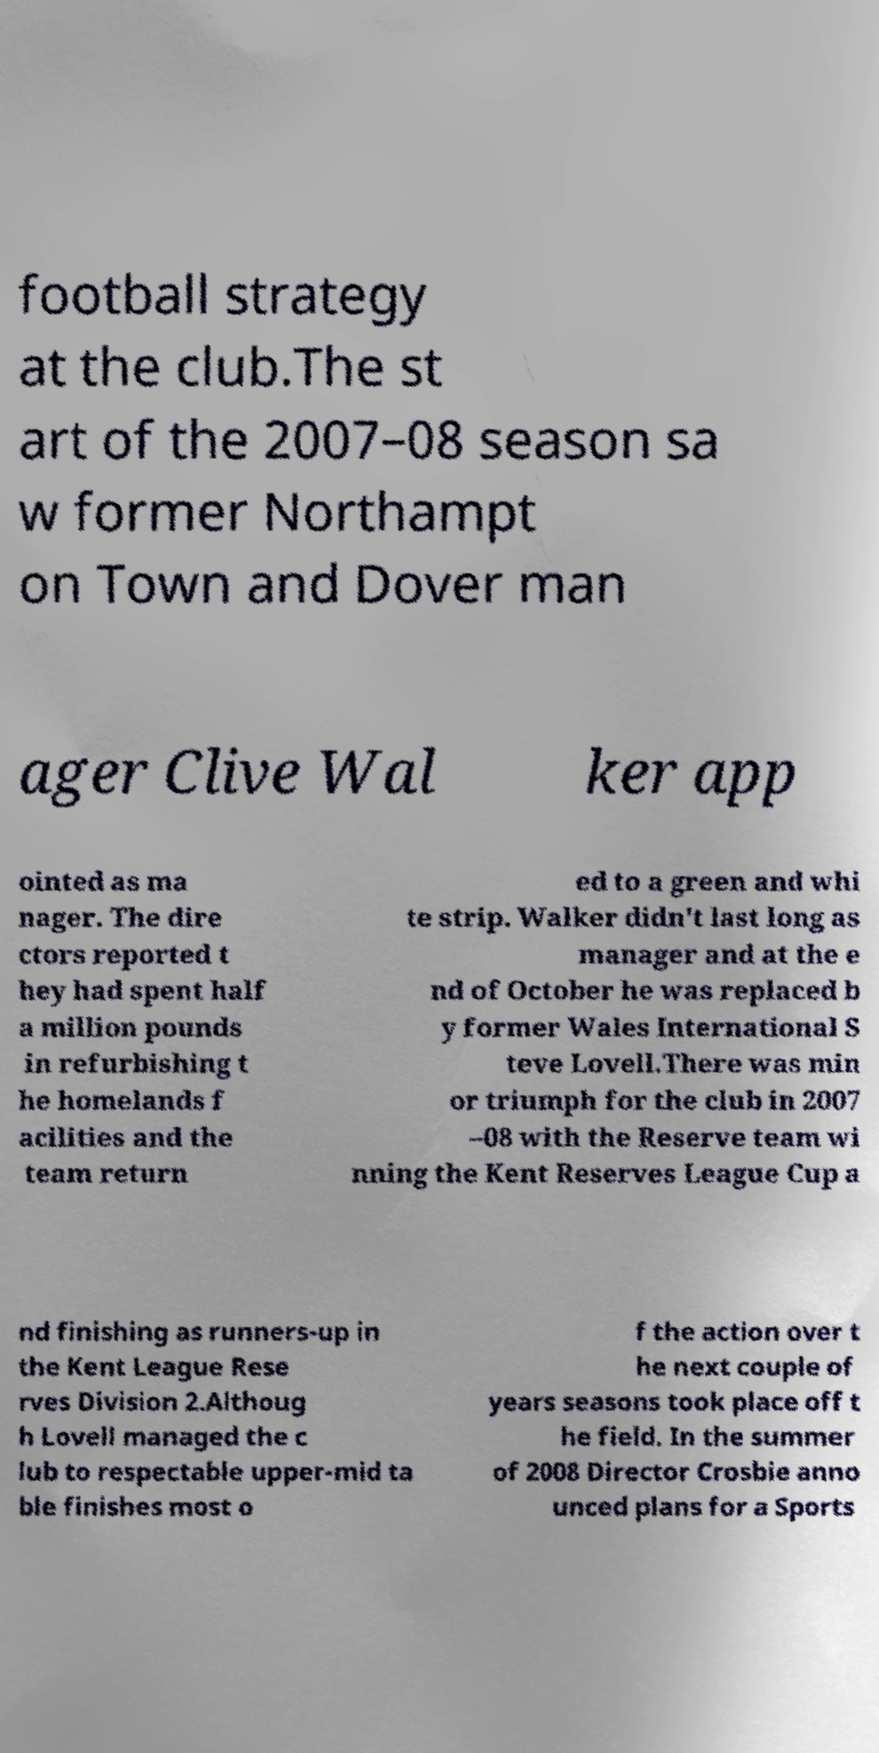I need the written content from this picture converted into text. Can you do that? football strategy at the club.The st art of the 2007–08 season sa w former Northampt on Town and Dover man ager Clive Wal ker app ointed as ma nager. The dire ctors reported t hey had spent half a million pounds in refurbishing t he homelands f acilities and the team return ed to a green and whi te strip. Walker didn't last long as manager and at the e nd of October he was replaced b y former Wales International S teve Lovell.There was min or triumph for the club in 2007 –08 with the Reserve team wi nning the Kent Reserves League Cup a nd finishing as runners-up in the Kent League Rese rves Division 2.Althoug h Lovell managed the c lub to respectable upper-mid ta ble finishes most o f the action over t he next couple of years seasons took place off t he field. In the summer of 2008 Director Crosbie anno unced plans for a Sports 